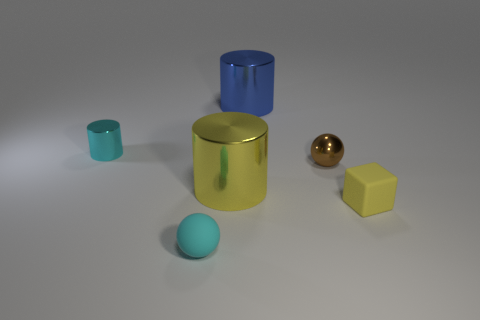How do the objects differ in terms of their surface texture? The objects exhibit various surface textures; the large yellow cylinder and the small blue cup have a reflective, glossy finish, whereas the yellow block, the sphere, and the teal egg-shaped object possess a matte, non-reflective surface. 